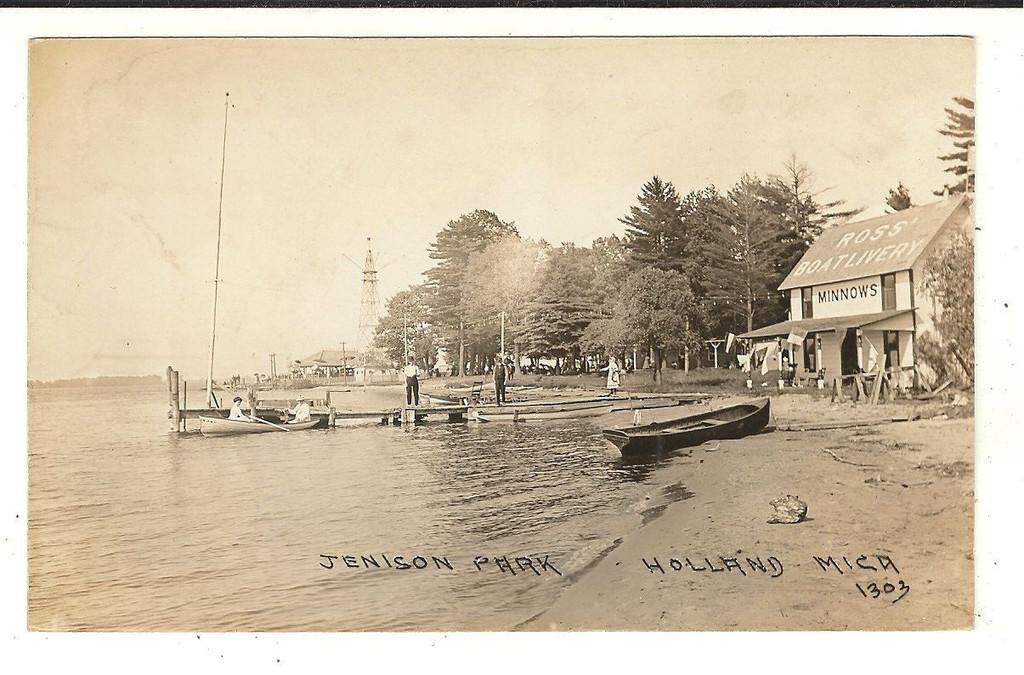What is happening in the image involving water? There are boats on water in the image. Can you describe the people visible in the image? There are people visible in the image. What type of structures can be seen in the image? There are sheds in the image. What other natural elements are present in the image? Trees are present in the image. What else can be seen in the image that might be related to the boats? Poles are visible in the image. What is visible in the background of the image? The sky is visible in the image. Is there any text present in the image? Yes, there is text at the bottom of the image. Can you tell me how many crackers are floating in the water near the boats? There are no crackers present in the image; it features boats on water. What type of chain is connecting the trees in the image? There is no chain connecting the trees in the image; only trees, poles, and sheds are present. 